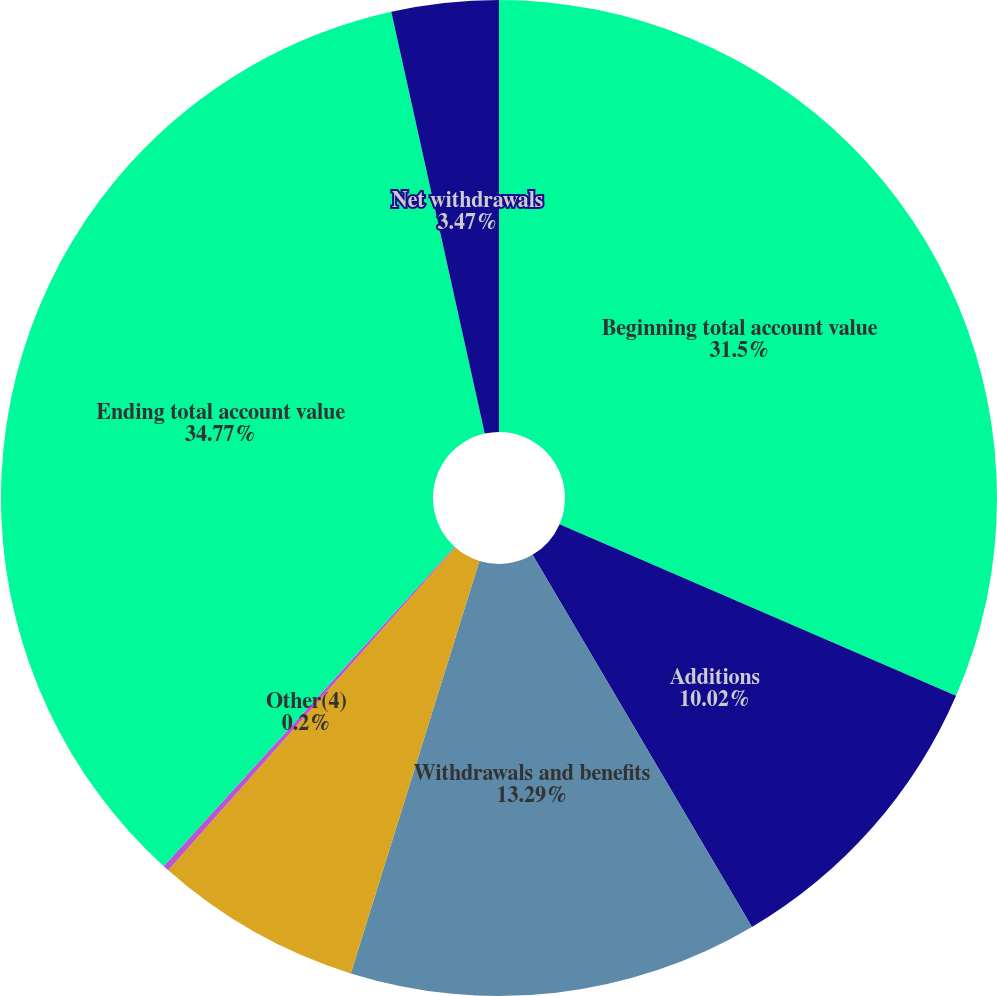Convert chart. <chart><loc_0><loc_0><loc_500><loc_500><pie_chart><fcel>Beginning total account value<fcel>Additions<fcel>Withdrawals and benefits<fcel>Change in market value<fcel>Other(4)<fcel>Ending total account value<fcel>Net withdrawals<nl><fcel>31.5%<fcel>10.02%<fcel>13.29%<fcel>6.75%<fcel>0.2%<fcel>34.77%<fcel>3.47%<nl></chart> 